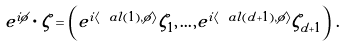<formula> <loc_0><loc_0><loc_500><loc_500>e ^ { i \phi } \cdot \zeta = \left ( e ^ { i \langle \ a l ( 1 ) , \phi \rangle } \zeta _ { 1 } , \dots , e ^ { i \langle \ a l ( d + 1 ) , \phi \rangle } \zeta _ { d + 1 } \right ) \, .</formula> 